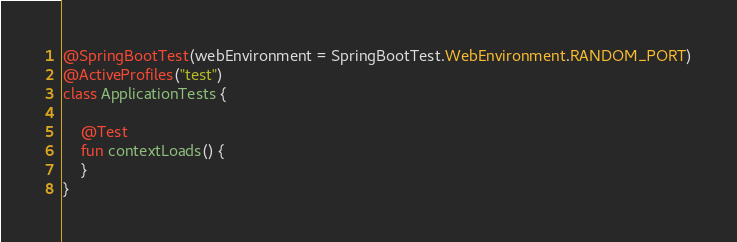<code> <loc_0><loc_0><loc_500><loc_500><_Kotlin_>@SpringBootTest(webEnvironment = SpringBootTest.WebEnvironment.RANDOM_PORT)
@ActiveProfiles("test")
class ApplicationTests {

    @Test
    fun contextLoads() {
    }
}
</code> 